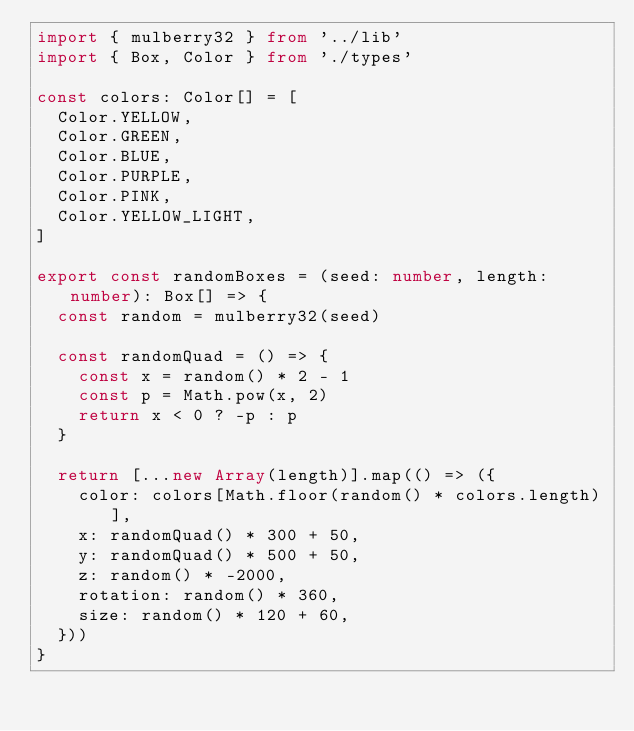<code> <loc_0><loc_0><loc_500><loc_500><_TypeScript_>import { mulberry32 } from '../lib'
import { Box, Color } from './types'

const colors: Color[] = [
  Color.YELLOW,
  Color.GREEN,
  Color.BLUE,
  Color.PURPLE,
  Color.PINK,
  Color.YELLOW_LIGHT,
]

export const randomBoxes = (seed: number, length: number): Box[] => {
  const random = mulberry32(seed)

  const randomQuad = () => {
    const x = random() * 2 - 1
    const p = Math.pow(x, 2)
    return x < 0 ? -p : p
  }

  return [...new Array(length)].map(() => ({
    color: colors[Math.floor(random() * colors.length)],
    x: randomQuad() * 300 + 50,
    y: randomQuad() * 500 + 50,
    z: random() * -2000,
    rotation: random() * 360,
    size: random() * 120 + 60,
  }))
}
</code> 